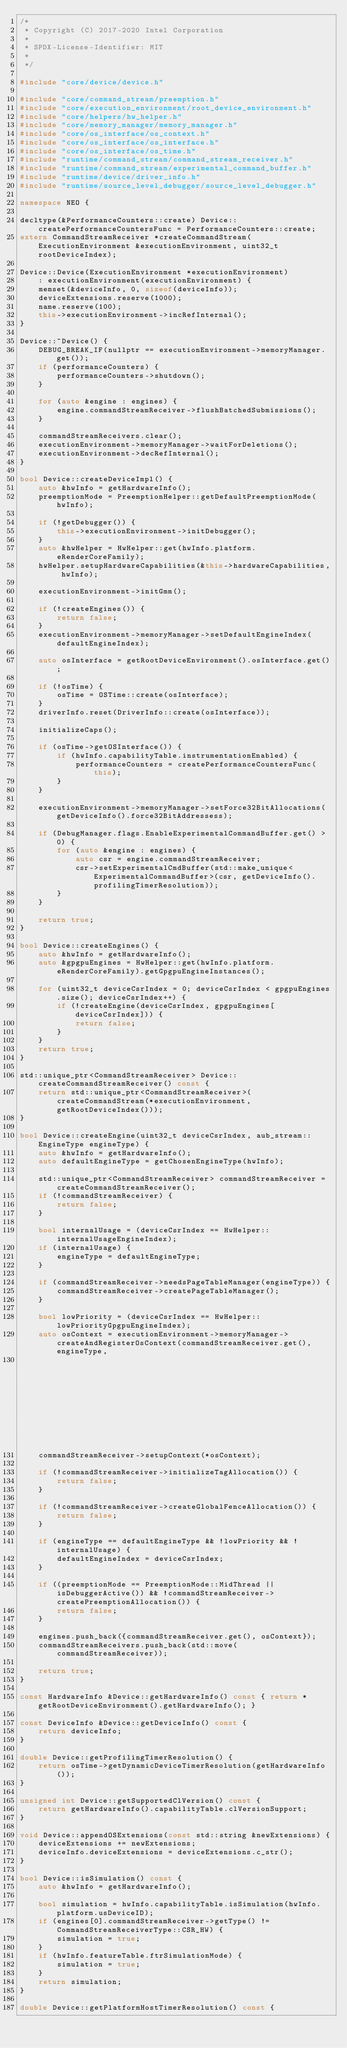<code> <loc_0><loc_0><loc_500><loc_500><_C++_>/*
 * Copyright (C) 2017-2020 Intel Corporation
 *
 * SPDX-License-Identifier: MIT
 *
 */

#include "core/device/device.h"

#include "core/command_stream/preemption.h"
#include "core/execution_environment/root_device_environment.h"
#include "core/helpers/hw_helper.h"
#include "core/memory_manager/memory_manager.h"
#include "core/os_interface/os_context.h"
#include "core/os_interface/os_interface.h"
#include "core/os_interface/os_time.h"
#include "runtime/command_stream/command_stream_receiver.h"
#include "runtime/command_stream/experimental_command_buffer.h"
#include "runtime/device/driver_info.h"
#include "runtime/source_level_debugger/source_level_debugger.h"

namespace NEO {

decltype(&PerformanceCounters::create) Device::createPerformanceCountersFunc = PerformanceCounters::create;
extern CommandStreamReceiver *createCommandStream(ExecutionEnvironment &executionEnvironment, uint32_t rootDeviceIndex);

Device::Device(ExecutionEnvironment *executionEnvironment)
    : executionEnvironment(executionEnvironment) {
    memset(&deviceInfo, 0, sizeof(deviceInfo));
    deviceExtensions.reserve(1000);
    name.reserve(100);
    this->executionEnvironment->incRefInternal();
}

Device::~Device() {
    DEBUG_BREAK_IF(nullptr == executionEnvironment->memoryManager.get());
    if (performanceCounters) {
        performanceCounters->shutdown();
    }

    for (auto &engine : engines) {
        engine.commandStreamReceiver->flushBatchedSubmissions();
    }

    commandStreamReceivers.clear();
    executionEnvironment->memoryManager->waitForDeletions();
    executionEnvironment->decRefInternal();
}

bool Device::createDeviceImpl() {
    auto &hwInfo = getHardwareInfo();
    preemptionMode = PreemptionHelper::getDefaultPreemptionMode(hwInfo);

    if (!getDebugger()) {
        this->executionEnvironment->initDebugger();
    }
    auto &hwHelper = HwHelper::get(hwInfo.platform.eRenderCoreFamily);
    hwHelper.setupHardwareCapabilities(&this->hardwareCapabilities, hwInfo);

    executionEnvironment->initGmm();

    if (!createEngines()) {
        return false;
    }
    executionEnvironment->memoryManager->setDefaultEngineIndex(defaultEngineIndex);

    auto osInterface = getRootDeviceEnvironment().osInterface.get();

    if (!osTime) {
        osTime = OSTime::create(osInterface);
    }
    driverInfo.reset(DriverInfo::create(osInterface));

    initializeCaps();

    if (osTime->getOSInterface()) {
        if (hwInfo.capabilityTable.instrumentationEnabled) {
            performanceCounters = createPerformanceCountersFunc(this);
        }
    }

    executionEnvironment->memoryManager->setForce32BitAllocations(getDeviceInfo().force32BitAddressess);

    if (DebugManager.flags.EnableExperimentalCommandBuffer.get() > 0) {
        for (auto &engine : engines) {
            auto csr = engine.commandStreamReceiver;
            csr->setExperimentalCmdBuffer(std::make_unique<ExperimentalCommandBuffer>(csr, getDeviceInfo().profilingTimerResolution));
        }
    }

    return true;
}

bool Device::createEngines() {
    auto &hwInfo = getHardwareInfo();
    auto &gpgpuEngines = HwHelper::get(hwInfo.platform.eRenderCoreFamily).getGpgpuEngineInstances();

    for (uint32_t deviceCsrIndex = 0; deviceCsrIndex < gpgpuEngines.size(); deviceCsrIndex++) {
        if (!createEngine(deviceCsrIndex, gpgpuEngines[deviceCsrIndex])) {
            return false;
        }
    }
    return true;
}

std::unique_ptr<CommandStreamReceiver> Device::createCommandStreamReceiver() const {
    return std::unique_ptr<CommandStreamReceiver>(createCommandStream(*executionEnvironment, getRootDeviceIndex()));
}

bool Device::createEngine(uint32_t deviceCsrIndex, aub_stream::EngineType engineType) {
    auto &hwInfo = getHardwareInfo();
    auto defaultEngineType = getChosenEngineType(hwInfo);

    std::unique_ptr<CommandStreamReceiver> commandStreamReceiver = createCommandStreamReceiver();
    if (!commandStreamReceiver) {
        return false;
    }

    bool internalUsage = (deviceCsrIndex == HwHelper::internalUsageEngineIndex);
    if (internalUsage) {
        engineType = defaultEngineType;
    }

    if (commandStreamReceiver->needsPageTableManager(engineType)) {
        commandStreamReceiver->createPageTableManager();
    }

    bool lowPriority = (deviceCsrIndex == HwHelper::lowPriorityGpgpuEngineIndex);
    auto osContext = executionEnvironment->memoryManager->createAndRegisterOsContext(commandStreamReceiver.get(), engineType,
                                                                                     getDeviceBitfield(), preemptionMode, lowPriority);
    commandStreamReceiver->setupContext(*osContext);

    if (!commandStreamReceiver->initializeTagAllocation()) {
        return false;
    }

    if (!commandStreamReceiver->createGlobalFenceAllocation()) {
        return false;
    }

    if (engineType == defaultEngineType && !lowPriority && !internalUsage) {
        defaultEngineIndex = deviceCsrIndex;
    }

    if ((preemptionMode == PreemptionMode::MidThread || isDebuggerActive()) && !commandStreamReceiver->createPreemptionAllocation()) {
        return false;
    }

    engines.push_back({commandStreamReceiver.get(), osContext});
    commandStreamReceivers.push_back(std::move(commandStreamReceiver));

    return true;
}

const HardwareInfo &Device::getHardwareInfo() const { return *getRootDeviceEnvironment().getHardwareInfo(); }

const DeviceInfo &Device::getDeviceInfo() const {
    return deviceInfo;
}

double Device::getProfilingTimerResolution() {
    return osTime->getDynamicDeviceTimerResolution(getHardwareInfo());
}

unsigned int Device::getSupportedClVersion() const {
    return getHardwareInfo().capabilityTable.clVersionSupport;
}

void Device::appendOSExtensions(const std::string &newExtensions) {
    deviceExtensions += newExtensions;
    deviceInfo.deviceExtensions = deviceExtensions.c_str();
}

bool Device::isSimulation() const {
    auto &hwInfo = getHardwareInfo();

    bool simulation = hwInfo.capabilityTable.isSimulation(hwInfo.platform.usDeviceID);
    if (engines[0].commandStreamReceiver->getType() != CommandStreamReceiverType::CSR_HW) {
        simulation = true;
    }
    if (hwInfo.featureTable.ftrSimulationMode) {
        simulation = true;
    }
    return simulation;
}

double Device::getPlatformHostTimerResolution() const {</code> 